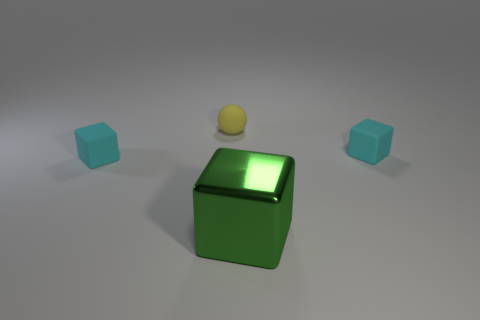Add 3 yellow rubber things. How many objects exist? 7 Subtract all small matte blocks. How many blocks are left? 1 Subtract 0 purple cubes. How many objects are left? 4 Subtract all balls. How many objects are left? 3 Subtract 3 blocks. How many blocks are left? 0 Subtract all cyan cubes. Subtract all gray cylinders. How many cubes are left? 1 Subtract all yellow blocks. How many gray balls are left? 0 Subtract all large yellow matte cubes. Subtract all metal blocks. How many objects are left? 3 Add 1 cyan rubber things. How many cyan rubber things are left? 3 Add 4 cubes. How many cubes exist? 7 